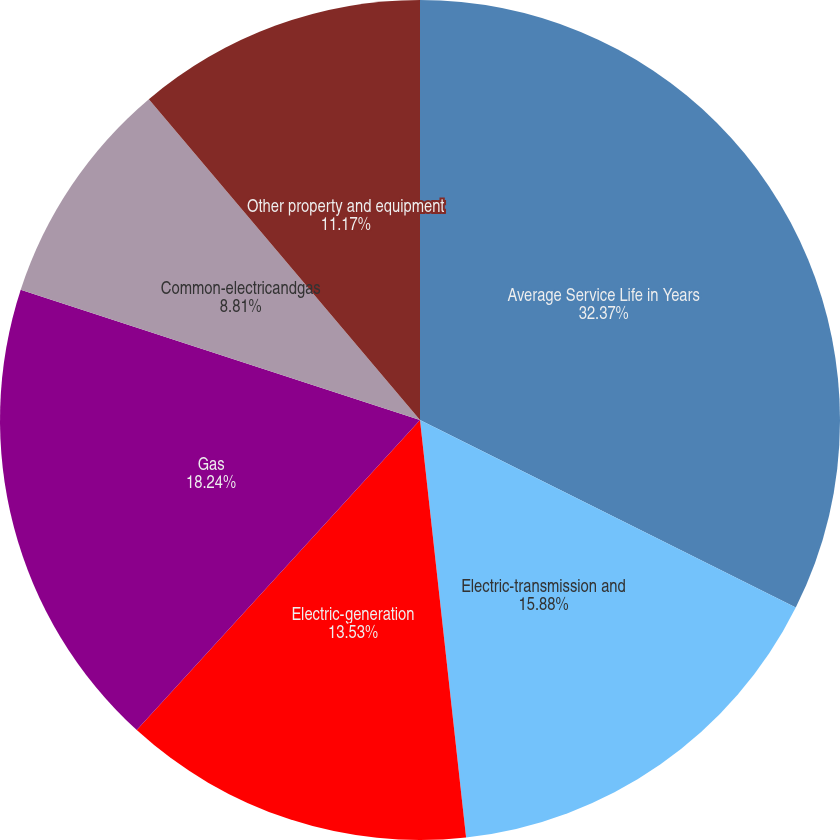Convert chart. <chart><loc_0><loc_0><loc_500><loc_500><pie_chart><fcel>Average Service Life in Years<fcel>Electric-transmission and<fcel>Electric-generation<fcel>Gas<fcel>Common-electricandgas<fcel>Other property and equipment<nl><fcel>32.37%<fcel>15.88%<fcel>13.53%<fcel>18.24%<fcel>8.81%<fcel>11.17%<nl></chart> 